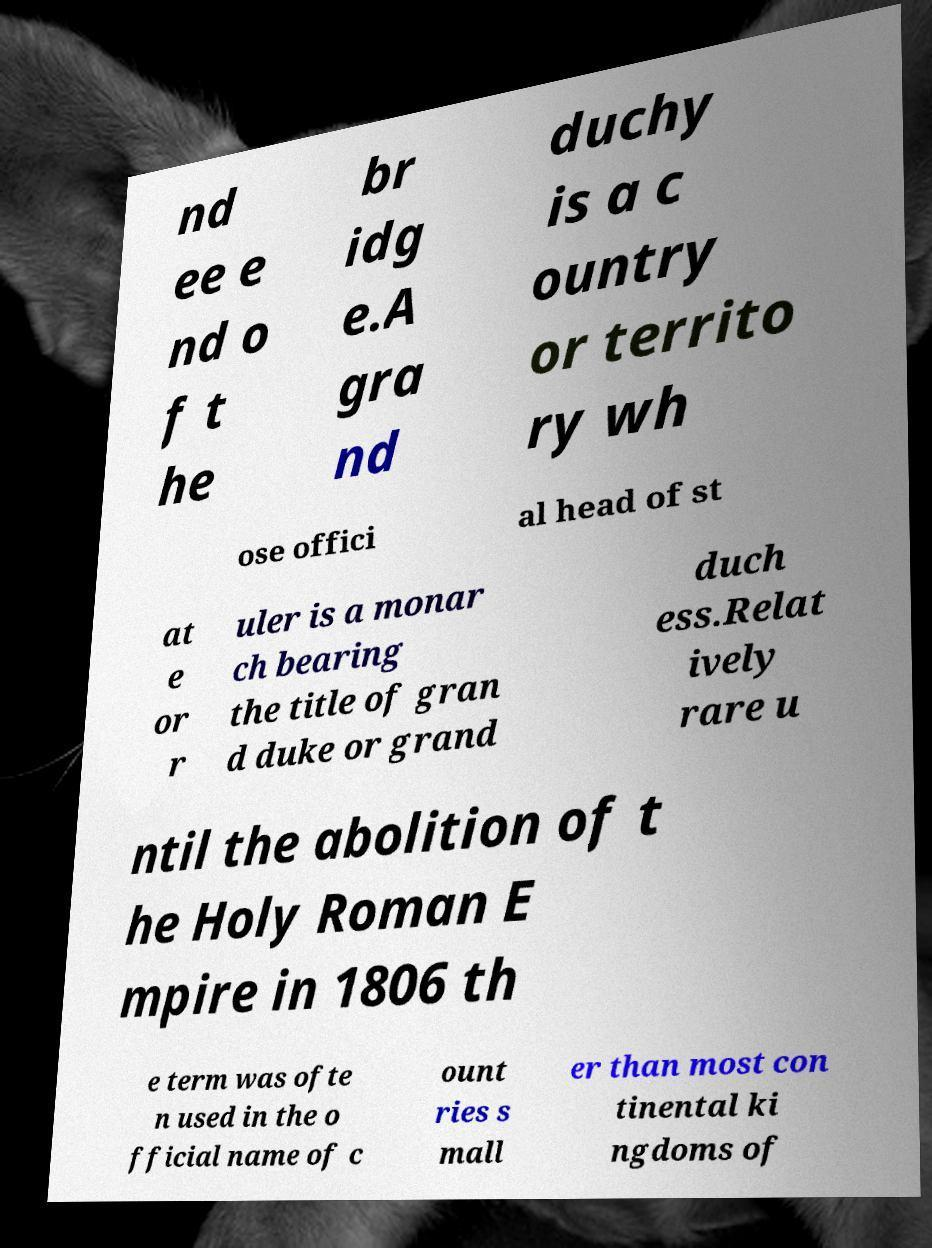There's text embedded in this image that I need extracted. Can you transcribe it verbatim? nd ee e nd o f t he br idg e.A gra nd duchy is a c ountry or territo ry wh ose offici al head of st at e or r uler is a monar ch bearing the title of gran d duke or grand duch ess.Relat ively rare u ntil the abolition of t he Holy Roman E mpire in 1806 th e term was ofte n used in the o fficial name of c ount ries s mall er than most con tinental ki ngdoms of 